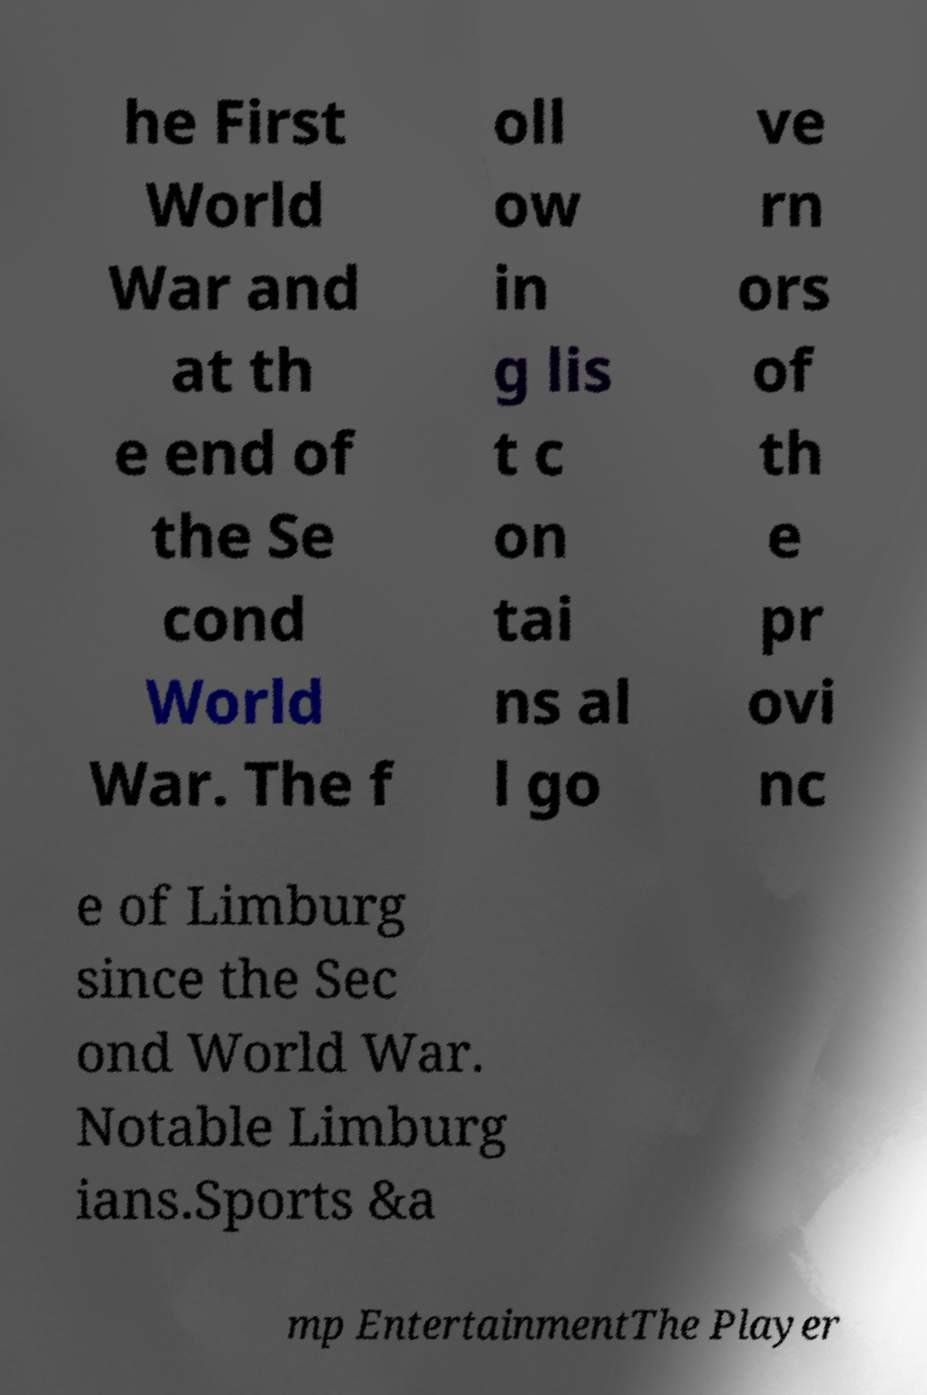Please read and relay the text visible in this image. What does it say? he First World War and at th e end of the Se cond World War. The f oll ow in g lis t c on tai ns al l go ve rn ors of th e pr ovi nc e of Limburg since the Sec ond World War. Notable Limburg ians.Sports &a mp EntertainmentThe Player 